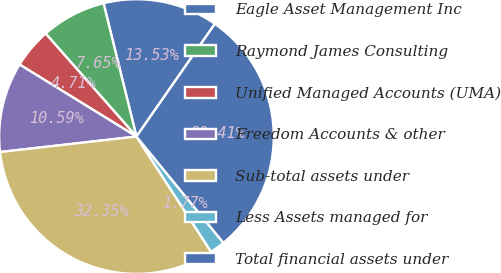<chart> <loc_0><loc_0><loc_500><loc_500><pie_chart><fcel>Eagle Asset Management Inc<fcel>Raymond James Consulting<fcel>Unified Managed Accounts (UMA)<fcel>Freedom Accounts & other<fcel>Sub-total assets under<fcel>Less Assets managed for<fcel>Total financial assets under<nl><fcel>13.53%<fcel>7.65%<fcel>4.71%<fcel>10.59%<fcel>32.35%<fcel>1.77%<fcel>29.41%<nl></chart> 